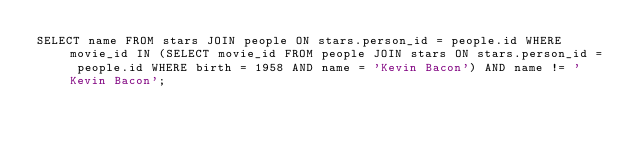Convert code to text. <code><loc_0><loc_0><loc_500><loc_500><_SQL_>SELECT name FROM stars JOIN people ON stars.person_id = people.id WHERE movie_id IN (SELECT movie_id FROM people JOIN stars ON stars.person_id = people.id WHERE birth = 1958 AND name = 'Kevin Bacon') AND name != 'Kevin Bacon';</code> 